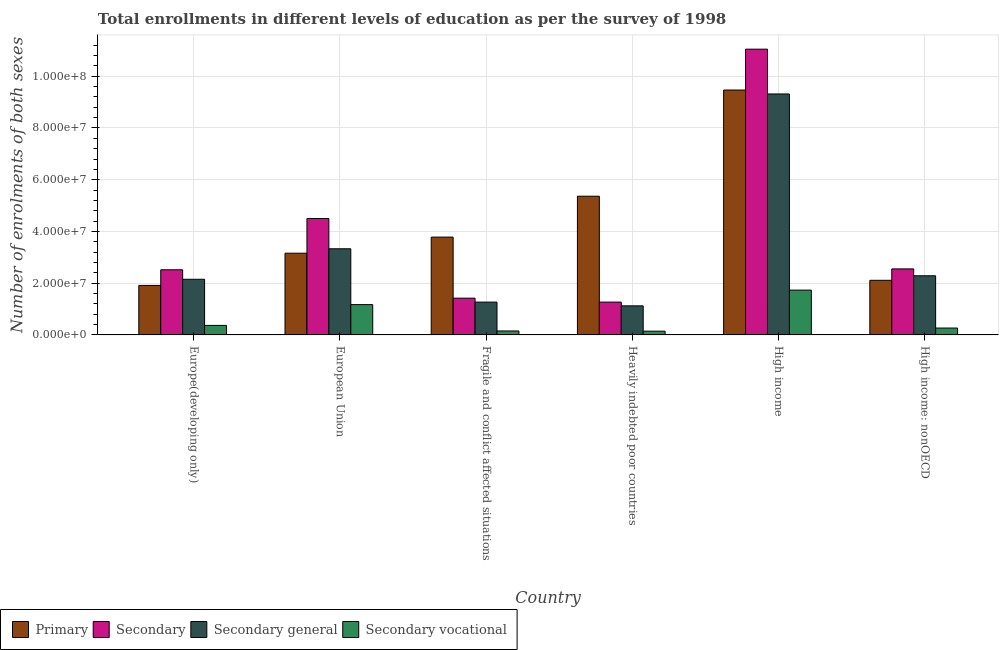How many different coloured bars are there?
Offer a very short reply. 4. How many bars are there on the 5th tick from the right?
Your answer should be very brief. 4. What is the label of the 4th group of bars from the left?
Your answer should be compact. Heavily indebted poor countries. What is the number of enrolments in primary education in Heavily indebted poor countries?
Your answer should be compact. 5.36e+07. Across all countries, what is the maximum number of enrolments in secondary education?
Your answer should be compact. 1.10e+08. Across all countries, what is the minimum number of enrolments in secondary education?
Make the answer very short. 1.27e+07. In which country was the number of enrolments in secondary general education maximum?
Provide a succinct answer. High income. In which country was the number of enrolments in secondary education minimum?
Offer a terse response. Heavily indebted poor countries. What is the total number of enrolments in primary education in the graph?
Your answer should be compact. 2.58e+08. What is the difference between the number of enrolments in secondary education in Europe(developing only) and that in Heavily indebted poor countries?
Your answer should be very brief. 1.25e+07. What is the difference between the number of enrolments in primary education in High income and the number of enrolments in secondary education in Fragile and conflict affected situations?
Make the answer very short. 8.05e+07. What is the average number of enrolments in secondary vocational education per country?
Ensure brevity in your answer.  6.39e+06. What is the difference between the number of enrolments in secondary education and number of enrolments in secondary vocational education in Europe(developing only)?
Give a very brief answer. 2.15e+07. What is the ratio of the number of enrolments in secondary general education in European Union to that in Fragile and conflict affected situations?
Provide a succinct answer. 2.63. What is the difference between the highest and the second highest number of enrolments in secondary vocational education?
Give a very brief answer. 5.61e+06. What is the difference between the highest and the lowest number of enrolments in secondary general education?
Your answer should be compact. 8.19e+07. In how many countries, is the number of enrolments in secondary vocational education greater than the average number of enrolments in secondary vocational education taken over all countries?
Your response must be concise. 2. Is it the case that in every country, the sum of the number of enrolments in secondary vocational education and number of enrolments in secondary general education is greater than the sum of number of enrolments in primary education and number of enrolments in secondary education?
Your response must be concise. No. What does the 2nd bar from the left in European Union represents?
Offer a very short reply. Secondary. What does the 3rd bar from the right in Fragile and conflict affected situations represents?
Ensure brevity in your answer.  Secondary. How many bars are there?
Ensure brevity in your answer.  24. Are all the bars in the graph horizontal?
Your response must be concise. No. How many countries are there in the graph?
Offer a terse response. 6. What is the difference between two consecutive major ticks on the Y-axis?
Your answer should be compact. 2.00e+07. Are the values on the major ticks of Y-axis written in scientific E-notation?
Your answer should be compact. Yes. Where does the legend appear in the graph?
Your answer should be compact. Bottom left. How many legend labels are there?
Provide a short and direct response. 4. How are the legend labels stacked?
Offer a terse response. Horizontal. What is the title of the graph?
Offer a very short reply. Total enrollments in different levels of education as per the survey of 1998. Does "Natural Gas" appear as one of the legend labels in the graph?
Provide a short and direct response. No. What is the label or title of the Y-axis?
Give a very brief answer. Number of enrolments of both sexes. What is the Number of enrolments of both sexes of Primary in Europe(developing only)?
Make the answer very short. 1.91e+07. What is the Number of enrolments of both sexes in Secondary in Europe(developing only)?
Offer a very short reply. 2.52e+07. What is the Number of enrolments of both sexes of Secondary general in Europe(developing only)?
Offer a terse response. 2.15e+07. What is the Number of enrolments of both sexes in Secondary vocational in Europe(developing only)?
Your answer should be compact. 3.67e+06. What is the Number of enrolments of both sexes in Primary in European Union?
Ensure brevity in your answer.  3.16e+07. What is the Number of enrolments of both sexes of Secondary in European Union?
Give a very brief answer. 4.50e+07. What is the Number of enrolments of both sexes of Secondary general in European Union?
Your response must be concise. 3.33e+07. What is the Number of enrolments of both sexes of Secondary vocational in European Union?
Provide a short and direct response. 1.17e+07. What is the Number of enrolments of both sexes of Primary in Fragile and conflict affected situations?
Your answer should be compact. 3.78e+07. What is the Number of enrolments of both sexes of Secondary in Fragile and conflict affected situations?
Ensure brevity in your answer.  1.42e+07. What is the Number of enrolments of both sexes in Secondary general in Fragile and conflict affected situations?
Provide a short and direct response. 1.27e+07. What is the Number of enrolments of both sexes of Secondary vocational in Fragile and conflict affected situations?
Offer a very short reply. 1.53e+06. What is the Number of enrolments of both sexes of Primary in Heavily indebted poor countries?
Your answer should be compact. 5.36e+07. What is the Number of enrolments of both sexes of Secondary in Heavily indebted poor countries?
Give a very brief answer. 1.27e+07. What is the Number of enrolments of both sexes in Secondary general in Heavily indebted poor countries?
Your answer should be very brief. 1.12e+07. What is the Number of enrolments of both sexes of Secondary vocational in Heavily indebted poor countries?
Your response must be concise. 1.45e+06. What is the Number of enrolments of both sexes of Primary in High income?
Provide a succinct answer. 9.47e+07. What is the Number of enrolments of both sexes of Secondary in High income?
Keep it short and to the point. 1.10e+08. What is the Number of enrolments of both sexes of Secondary general in High income?
Provide a short and direct response. 9.31e+07. What is the Number of enrolments of both sexes in Secondary vocational in High income?
Your answer should be compact. 1.73e+07. What is the Number of enrolments of both sexes in Primary in High income: nonOECD?
Your response must be concise. 2.11e+07. What is the Number of enrolments of both sexes in Secondary in High income: nonOECD?
Offer a very short reply. 2.55e+07. What is the Number of enrolments of both sexes of Secondary general in High income: nonOECD?
Your answer should be very brief. 2.29e+07. What is the Number of enrolments of both sexes in Secondary vocational in High income: nonOECD?
Offer a very short reply. 2.66e+06. Across all countries, what is the maximum Number of enrolments of both sexes in Primary?
Keep it short and to the point. 9.47e+07. Across all countries, what is the maximum Number of enrolments of both sexes of Secondary?
Provide a short and direct response. 1.10e+08. Across all countries, what is the maximum Number of enrolments of both sexes of Secondary general?
Make the answer very short. 9.31e+07. Across all countries, what is the maximum Number of enrolments of both sexes of Secondary vocational?
Ensure brevity in your answer.  1.73e+07. Across all countries, what is the minimum Number of enrolments of both sexes of Primary?
Your answer should be compact. 1.91e+07. Across all countries, what is the minimum Number of enrolments of both sexes in Secondary?
Your answer should be compact. 1.27e+07. Across all countries, what is the minimum Number of enrolments of both sexes of Secondary general?
Give a very brief answer. 1.12e+07. Across all countries, what is the minimum Number of enrolments of both sexes of Secondary vocational?
Provide a short and direct response. 1.45e+06. What is the total Number of enrolments of both sexes of Primary in the graph?
Your answer should be compact. 2.58e+08. What is the total Number of enrolments of both sexes of Secondary in the graph?
Give a very brief answer. 2.33e+08. What is the total Number of enrolments of both sexes in Secondary general in the graph?
Make the answer very short. 1.95e+08. What is the total Number of enrolments of both sexes of Secondary vocational in the graph?
Provide a succinct answer. 3.83e+07. What is the difference between the Number of enrolments of both sexes in Primary in Europe(developing only) and that in European Union?
Give a very brief answer. -1.25e+07. What is the difference between the Number of enrolments of both sexes of Secondary in Europe(developing only) and that in European Union?
Your answer should be very brief. -1.98e+07. What is the difference between the Number of enrolments of both sexes of Secondary general in Europe(developing only) and that in European Union?
Offer a very short reply. -1.18e+07. What is the difference between the Number of enrolments of both sexes in Secondary vocational in Europe(developing only) and that in European Union?
Give a very brief answer. -8.04e+06. What is the difference between the Number of enrolments of both sexes of Primary in Europe(developing only) and that in Fragile and conflict affected situations?
Offer a terse response. -1.87e+07. What is the difference between the Number of enrolments of both sexes in Secondary in Europe(developing only) and that in Fragile and conflict affected situations?
Give a very brief answer. 1.10e+07. What is the difference between the Number of enrolments of both sexes of Secondary general in Europe(developing only) and that in Fragile and conflict affected situations?
Make the answer very short. 8.83e+06. What is the difference between the Number of enrolments of both sexes in Secondary vocational in Europe(developing only) and that in Fragile and conflict affected situations?
Offer a terse response. 2.14e+06. What is the difference between the Number of enrolments of both sexes in Primary in Europe(developing only) and that in Heavily indebted poor countries?
Give a very brief answer. -3.45e+07. What is the difference between the Number of enrolments of both sexes in Secondary in Europe(developing only) and that in Heavily indebted poor countries?
Offer a terse response. 1.25e+07. What is the difference between the Number of enrolments of both sexes in Secondary general in Europe(developing only) and that in Heavily indebted poor countries?
Keep it short and to the point. 1.03e+07. What is the difference between the Number of enrolments of both sexes in Secondary vocational in Europe(developing only) and that in Heavily indebted poor countries?
Give a very brief answer. 2.22e+06. What is the difference between the Number of enrolments of both sexes in Primary in Europe(developing only) and that in High income?
Offer a very short reply. -7.55e+07. What is the difference between the Number of enrolments of both sexes of Secondary in Europe(developing only) and that in High income?
Make the answer very short. -8.53e+07. What is the difference between the Number of enrolments of both sexes of Secondary general in Europe(developing only) and that in High income?
Your response must be concise. -7.16e+07. What is the difference between the Number of enrolments of both sexes in Secondary vocational in Europe(developing only) and that in High income?
Give a very brief answer. -1.36e+07. What is the difference between the Number of enrolments of both sexes in Primary in Europe(developing only) and that in High income: nonOECD?
Provide a succinct answer. -1.98e+06. What is the difference between the Number of enrolments of both sexes of Secondary in Europe(developing only) and that in High income: nonOECD?
Your answer should be compact. -3.42e+05. What is the difference between the Number of enrolments of both sexes in Secondary general in Europe(developing only) and that in High income: nonOECD?
Your answer should be compact. -1.35e+06. What is the difference between the Number of enrolments of both sexes of Secondary vocational in Europe(developing only) and that in High income: nonOECD?
Your answer should be compact. 1.01e+06. What is the difference between the Number of enrolments of both sexes of Primary in European Union and that in Fragile and conflict affected situations?
Your answer should be compact. -6.23e+06. What is the difference between the Number of enrolments of both sexes of Secondary in European Union and that in Fragile and conflict affected situations?
Offer a terse response. 3.08e+07. What is the difference between the Number of enrolments of both sexes in Secondary general in European Union and that in Fragile and conflict affected situations?
Ensure brevity in your answer.  2.06e+07. What is the difference between the Number of enrolments of both sexes in Secondary vocational in European Union and that in Fragile and conflict affected situations?
Your answer should be very brief. 1.02e+07. What is the difference between the Number of enrolments of both sexes in Primary in European Union and that in Heavily indebted poor countries?
Make the answer very short. -2.20e+07. What is the difference between the Number of enrolments of both sexes in Secondary in European Union and that in Heavily indebted poor countries?
Offer a terse response. 3.23e+07. What is the difference between the Number of enrolments of both sexes in Secondary general in European Union and that in Heavily indebted poor countries?
Ensure brevity in your answer.  2.21e+07. What is the difference between the Number of enrolments of both sexes in Secondary vocational in European Union and that in Heavily indebted poor countries?
Offer a terse response. 1.03e+07. What is the difference between the Number of enrolments of both sexes in Primary in European Union and that in High income?
Provide a short and direct response. -6.31e+07. What is the difference between the Number of enrolments of both sexes in Secondary in European Union and that in High income?
Give a very brief answer. -6.55e+07. What is the difference between the Number of enrolments of both sexes of Secondary general in European Union and that in High income?
Ensure brevity in your answer.  -5.99e+07. What is the difference between the Number of enrolments of both sexes in Secondary vocational in European Union and that in High income?
Keep it short and to the point. -5.61e+06. What is the difference between the Number of enrolments of both sexes of Primary in European Union and that in High income: nonOECD?
Make the answer very short. 1.05e+07. What is the difference between the Number of enrolments of both sexes of Secondary in European Union and that in High income: nonOECD?
Provide a short and direct response. 1.95e+07. What is the difference between the Number of enrolments of both sexes of Secondary general in European Union and that in High income: nonOECD?
Offer a very short reply. 1.04e+07. What is the difference between the Number of enrolments of both sexes in Secondary vocational in European Union and that in High income: nonOECD?
Provide a short and direct response. 9.05e+06. What is the difference between the Number of enrolments of both sexes in Primary in Fragile and conflict affected situations and that in Heavily indebted poor countries?
Provide a short and direct response. -1.58e+07. What is the difference between the Number of enrolments of both sexes of Secondary in Fragile and conflict affected situations and that in Heavily indebted poor countries?
Your answer should be compact. 1.52e+06. What is the difference between the Number of enrolments of both sexes of Secondary general in Fragile and conflict affected situations and that in Heavily indebted poor countries?
Your answer should be very brief. 1.45e+06. What is the difference between the Number of enrolments of both sexes in Secondary vocational in Fragile and conflict affected situations and that in Heavily indebted poor countries?
Your response must be concise. 7.78e+04. What is the difference between the Number of enrolments of both sexes of Primary in Fragile and conflict affected situations and that in High income?
Your answer should be very brief. -5.69e+07. What is the difference between the Number of enrolments of both sexes in Secondary in Fragile and conflict affected situations and that in High income?
Offer a very short reply. -9.63e+07. What is the difference between the Number of enrolments of both sexes in Secondary general in Fragile and conflict affected situations and that in High income?
Provide a succinct answer. -8.05e+07. What is the difference between the Number of enrolments of both sexes of Secondary vocational in Fragile and conflict affected situations and that in High income?
Offer a terse response. -1.58e+07. What is the difference between the Number of enrolments of both sexes in Primary in Fragile and conflict affected situations and that in High income: nonOECD?
Provide a short and direct response. 1.67e+07. What is the difference between the Number of enrolments of both sexes in Secondary in Fragile and conflict affected situations and that in High income: nonOECD?
Your answer should be compact. -1.13e+07. What is the difference between the Number of enrolments of both sexes of Secondary general in Fragile and conflict affected situations and that in High income: nonOECD?
Ensure brevity in your answer.  -1.02e+07. What is the difference between the Number of enrolments of both sexes in Secondary vocational in Fragile and conflict affected situations and that in High income: nonOECD?
Your response must be concise. -1.13e+06. What is the difference between the Number of enrolments of both sexes of Primary in Heavily indebted poor countries and that in High income?
Offer a very short reply. -4.10e+07. What is the difference between the Number of enrolments of both sexes of Secondary in Heavily indebted poor countries and that in High income?
Provide a succinct answer. -9.78e+07. What is the difference between the Number of enrolments of both sexes in Secondary general in Heavily indebted poor countries and that in High income?
Offer a terse response. -8.19e+07. What is the difference between the Number of enrolments of both sexes in Secondary vocational in Heavily indebted poor countries and that in High income?
Give a very brief answer. -1.59e+07. What is the difference between the Number of enrolments of both sexes of Primary in Heavily indebted poor countries and that in High income: nonOECD?
Your answer should be very brief. 3.25e+07. What is the difference between the Number of enrolments of both sexes in Secondary in Heavily indebted poor countries and that in High income: nonOECD?
Your response must be concise. -1.28e+07. What is the difference between the Number of enrolments of both sexes in Secondary general in Heavily indebted poor countries and that in High income: nonOECD?
Your answer should be compact. -1.16e+07. What is the difference between the Number of enrolments of both sexes in Secondary vocational in Heavily indebted poor countries and that in High income: nonOECD?
Ensure brevity in your answer.  -1.21e+06. What is the difference between the Number of enrolments of both sexes of Primary in High income and that in High income: nonOECD?
Provide a short and direct response. 7.36e+07. What is the difference between the Number of enrolments of both sexes of Secondary in High income and that in High income: nonOECD?
Offer a terse response. 8.49e+07. What is the difference between the Number of enrolments of both sexes of Secondary general in High income and that in High income: nonOECD?
Give a very brief answer. 7.03e+07. What is the difference between the Number of enrolments of both sexes of Secondary vocational in High income and that in High income: nonOECD?
Make the answer very short. 1.47e+07. What is the difference between the Number of enrolments of both sexes in Primary in Europe(developing only) and the Number of enrolments of both sexes in Secondary in European Union?
Give a very brief answer. -2.59e+07. What is the difference between the Number of enrolments of both sexes in Primary in Europe(developing only) and the Number of enrolments of both sexes in Secondary general in European Union?
Provide a short and direct response. -1.42e+07. What is the difference between the Number of enrolments of both sexes in Primary in Europe(developing only) and the Number of enrolments of both sexes in Secondary vocational in European Union?
Give a very brief answer. 7.42e+06. What is the difference between the Number of enrolments of both sexes in Secondary in Europe(developing only) and the Number of enrolments of both sexes in Secondary general in European Union?
Ensure brevity in your answer.  -8.12e+06. What is the difference between the Number of enrolments of both sexes of Secondary in Europe(developing only) and the Number of enrolments of both sexes of Secondary vocational in European Union?
Provide a succinct answer. 1.35e+07. What is the difference between the Number of enrolments of both sexes of Secondary general in Europe(developing only) and the Number of enrolments of both sexes of Secondary vocational in European Union?
Offer a terse response. 9.80e+06. What is the difference between the Number of enrolments of both sexes of Primary in Europe(developing only) and the Number of enrolments of both sexes of Secondary in Fragile and conflict affected situations?
Provide a succinct answer. 4.92e+06. What is the difference between the Number of enrolments of both sexes in Primary in Europe(developing only) and the Number of enrolments of both sexes in Secondary general in Fragile and conflict affected situations?
Offer a very short reply. 6.45e+06. What is the difference between the Number of enrolments of both sexes of Primary in Europe(developing only) and the Number of enrolments of both sexes of Secondary vocational in Fragile and conflict affected situations?
Make the answer very short. 1.76e+07. What is the difference between the Number of enrolments of both sexes of Secondary in Europe(developing only) and the Number of enrolments of both sexes of Secondary general in Fragile and conflict affected situations?
Provide a short and direct response. 1.25e+07. What is the difference between the Number of enrolments of both sexes in Secondary in Europe(developing only) and the Number of enrolments of both sexes in Secondary vocational in Fragile and conflict affected situations?
Offer a very short reply. 2.37e+07. What is the difference between the Number of enrolments of both sexes in Secondary general in Europe(developing only) and the Number of enrolments of both sexes in Secondary vocational in Fragile and conflict affected situations?
Your answer should be compact. 2.00e+07. What is the difference between the Number of enrolments of both sexes in Primary in Europe(developing only) and the Number of enrolments of both sexes in Secondary in Heavily indebted poor countries?
Keep it short and to the point. 6.45e+06. What is the difference between the Number of enrolments of both sexes in Primary in Europe(developing only) and the Number of enrolments of both sexes in Secondary general in Heavily indebted poor countries?
Provide a short and direct response. 7.90e+06. What is the difference between the Number of enrolments of both sexes of Primary in Europe(developing only) and the Number of enrolments of both sexes of Secondary vocational in Heavily indebted poor countries?
Provide a short and direct response. 1.77e+07. What is the difference between the Number of enrolments of both sexes in Secondary in Europe(developing only) and the Number of enrolments of both sexes in Secondary general in Heavily indebted poor countries?
Make the answer very short. 1.39e+07. What is the difference between the Number of enrolments of both sexes in Secondary in Europe(developing only) and the Number of enrolments of both sexes in Secondary vocational in Heavily indebted poor countries?
Offer a very short reply. 2.37e+07. What is the difference between the Number of enrolments of both sexes of Secondary general in Europe(developing only) and the Number of enrolments of both sexes of Secondary vocational in Heavily indebted poor countries?
Give a very brief answer. 2.01e+07. What is the difference between the Number of enrolments of both sexes in Primary in Europe(developing only) and the Number of enrolments of both sexes in Secondary in High income?
Your answer should be compact. -9.13e+07. What is the difference between the Number of enrolments of both sexes of Primary in Europe(developing only) and the Number of enrolments of both sexes of Secondary general in High income?
Offer a very short reply. -7.40e+07. What is the difference between the Number of enrolments of both sexes in Primary in Europe(developing only) and the Number of enrolments of both sexes in Secondary vocational in High income?
Your answer should be compact. 1.81e+06. What is the difference between the Number of enrolments of both sexes in Secondary in Europe(developing only) and the Number of enrolments of both sexes in Secondary general in High income?
Provide a short and direct response. -6.80e+07. What is the difference between the Number of enrolments of both sexes in Secondary in Europe(developing only) and the Number of enrolments of both sexes in Secondary vocational in High income?
Your response must be concise. 7.86e+06. What is the difference between the Number of enrolments of both sexes of Secondary general in Europe(developing only) and the Number of enrolments of both sexes of Secondary vocational in High income?
Give a very brief answer. 4.19e+06. What is the difference between the Number of enrolments of both sexes of Primary in Europe(developing only) and the Number of enrolments of both sexes of Secondary in High income: nonOECD?
Provide a short and direct response. -6.39e+06. What is the difference between the Number of enrolments of both sexes of Primary in Europe(developing only) and the Number of enrolments of both sexes of Secondary general in High income: nonOECD?
Your response must be concise. -3.73e+06. What is the difference between the Number of enrolments of both sexes in Primary in Europe(developing only) and the Number of enrolments of both sexes in Secondary vocational in High income: nonOECD?
Your answer should be very brief. 1.65e+07. What is the difference between the Number of enrolments of both sexes of Secondary in Europe(developing only) and the Number of enrolments of both sexes of Secondary general in High income: nonOECD?
Give a very brief answer. 2.32e+06. What is the difference between the Number of enrolments of both sexes in Secondary in Europe(developing only) and the Number of enrolments of both sexes in Secondary vocational in High income: nonOECD?
Offer a very short reply. 2.25e+07. What is the difference between the Number of enrolments of both sexes of Secondary general in Europe(developing only) and the Number of enrolments of both sexes of Secondary vocational in High income: nonOECD?
Make the answer very short. 1.89e+07. What is the difference between the Number of enrolments of both sexes in Primary in European Union and the Number of enrolments of both sexes in Secondary in Fragile and conflict affected situations?
Ensure brevity in your answer.  1.74e+07. What is the difference between the Number of enrolments of both sexes in Primary in European Union and the Number of enrolments of both sexes in Secondary general in Fragile and conflict affected situations?
Give a very brief answer. 1.89e+07. What is the difference between the Number of enrolments of both sexes in Primary in European Union and the Number of enrolments of both sexes in Secondary vocational in Fragile and conflict affected situations?
Provide a succinct answer. 3.01e+07. What is the difference between the Number of enrolments of both sexes of Secondary in European Union and the Number of enrolments of both sexes of Secondary general in Fragile and conflict affected situations?
Provide a succinct answer. 3.23e+07. What is the difference between the Number of enrolments of both sexes in Secondary in European Union and the Number of enrolments of both sexes in Secondary vocational in Fragile and conflict affected situations?
Offer a very short reply. 4.35e+07. What is the difference between the Number of enrolments of both sexes in Secondary general in European Union and the Number of enrolments of both sexes in Secondary vocational in Fragile and conflict affected situations?
Your answer should be compact. 3.18e+07. What is the difference between the Number of enrolments of both sexes in Primary in European Union and the Number of enrolments of both sexes in Secondary in Heavily indebted poor countries?
Your answer should be compact. 1.89e+07. What is the difference between the Number of enrolments of both sexes in Primary in European Union and the Number of enrolments of both sexes in Secondary general in Heavily indebted poor countries?
Provide a short and direct response. 2.04e+07. What is the difference between the Number of enrolments of both sexes in Primary in European Union and the Number of enrolments of both sexes in Secondary vocational in Heavily indebted poor countries?
Offer a very short reply. 3.01e+07. What is the difference between the Number of enrolments of both sexes in Secondary in European Union and the Number of enrolments of both sexes in Secondary general in Heavily indebted poor countries?
Provide a short and direct response. 3.38e+07. What is the difference between the Number of enrolments of both sexes in Secondary in European Union and the Number of enrolments of both sexes in Secondary vocational in Heavily indebted poor countries?
Your answer should be compact. 4.36e+07. What is the difference between the Number of enrolments of both sexes of Secondary general in European Union and the Number of enrolments of both sexes of Secondary vocational in Heavily indebted poor countries?
Your answer should be compact. 3.18e+07. What is the difference between the Number of enrolments of both sexes of Primary in European Union and the Number of enrolments of both sexes of Secondary in High income?
Keep it short and to the point. -7.89e+07. What is the difference between the Number of enrolments of both sexes in Primary in European Union and the Number of enrolments of both sexes in Secondary general in High income?
Offer a terse response. -6.16e+07. What is the difference between the Number of enrolments of both sexes of Primary in European Union and the Number of enrolments of both sexes of Secondary vocational in High income?
Your response must be concise. 1.43e+07. What is the difference between the Number of enrolments of both sexes of Secondary in European Union and the Number of enrolments of both sexes of Secondary general in High income?
Provide a succinct answer. -4.81e+07. What is the difference between the Number of enrolments of both sexes of Secondary in European Union and the Number of enrolments of both sexes of Secondary vocational in High income?
Your answer should be compact. 2.77e+07. What is the difference between the Number of enrolments of both sexes of Secondary general in European Union and the Number of enrolments of both sexes of Secondary vocational in High income?
Provide a short and direct response. 1.60e+07. What is the difference between the Number of enrolments of both sexes in Primary in European Union and the Number of enrolments of both sexes in Secondary in High income: nonOECD?
Your response must be concise. 6.07e+06. What is the difference between the Number of enrolments of both sexes in Primary in European Union and the Number of enrolments of both sexes in Secondary general in High income: nonOECD?
Provide a succinct answer. 8.72e+06. What is the difference between the Number of enrolments of both sexes in Primary in European Union and the Number of enrolments of both sexes in Secondary vocational in High income: nonOECD?
Provide a succinct answer. 2.89e+07. What is the difference between the Number of enrolments of both sexes in Secondary in European Union and the Number of enrolments of both sexes in Secondary general in High income: nonOECD?
Make the answer very short. 2.21e+07. What is the difference between the Number of enrolments of both sexes of Secondary in European Union and the Number of enrolments of both sexes of Secondary vocational in High income: nonOECD?
Your answer should be compact. 4.23e+07. What is the difference between the Number of enrolments of both sexes of Secondary general in European Union and the Number of enrolments of both sexes of Secondary vocational in High income: nonOECD?
Ensure brevity in your answer.  3.06e+07. What is the difference between the Number of enrolments of both sexes in Primary in Fragile and conflict affected situations and the Number of enrolments of both sexes in Secondary in Heavily indebted poor countries?
Offer a terse response. 2.51e+07. What is the difference between the Number of enrolments of both sexes in Primary in Fragile and conflict affected situations and the Number of enrolments of both sexes in Secondary general in Heavily indebted poor countries?
Your response must be concise. 2.66e+07. What is the difference between the Number of enrolments of both sexes in Primary in Fragile and conflict affected situations and the Number of enrolments of both sexes in Secondary vocational in Heavily indebted poor countries?
Your response must be concise. 3.64e+07. What is the difference between the Number of enrolments of both sexes of Secondary in Fragile and conflict affected situations and the Number of enrolments of both sexes of Secondary general in Heavily indebted poor countries?
Make the answer very short. 2.97e+06. What is the difference between the Number of enrolments of both sexes in Secondary in Fragile and conflict affected situations and the Number of enrolments of both sexes in Secondary vocational in Heavily indebted poor countries?
Keep it short and to the point. 1.28e+07. What is the difference between the Number of enrolments of both sexes in Secondary general in Fragile and conflict affected situations and the Number of enrolments of both sexes in Secondary vocational in Heavily indebted poor countries?
Provide a succinct answer. 1.12e+07. What is the difference between the Number of enrolments of both sexes of Primary in Fragile and conflict affected situations and the Number of enrolments of both sexes of Secondary in High income?
Your answer should be very brief. -7.27e+07. What is the difference between the Number of enrolments of both sexes in Primary in Fragile and conflict affected situations and the Number of enrolments of both sexes in Secondary general in High income?
Offer a terse response. -5.53e+07. What is the difference between the Number of enrolments of both sexes in Primary in Fragile and conflict affected situations and the Number of enrolments of both sexes in Secondary vocational in High income?
Provide a succinct answer. 2.05e+07. What is the difference between the Number of enrolments of both sexes of Secondary in Fragile and conflict affected situations and the Number of enrolments of both sexes of Secondary general in High income?
Make the answer very short. -7.89e+07. What is the difference between the Number of enrolments of both sexes in Secondary in Fragile and conflict affected situations and the Number of enrolments of both sexes in Secondary vocational in High income?
Provide a succinct answer. -3.11e+06. What is the difference between the Number of enrolments of both sexes of Secondary general in Fragile and conflict affected situations and the Number of enrolments of both sexes of Secondary vocational in High income?
Provide a short and direct response. -4.64e+06. What is the difference between the Number of enrolments of both sexes in Primary in Fragile and conflict affected situations and the Number of enrolments of both sexes in Secondary in High income: nonOECD?
Provide a succinct answer. 1.23e+07. What is the difference between the Number of enrolments of both sexes in Primary in Fragile and conflict affected situations and the Number of enrolments of both sexes in Secondary general in High income: nonOECD?
Your response must be concise. 1.50e+07. What is the difference between the Number of enrolments of both sexes in Primary in Fragile and conflict affected situations and the Number of enrolments of both sexes in Secondary vocational in High income: nonOECD?
Keep it short and to the point. 3.52e+07. What is the difference between the Number of enrolments of both sexes in Secondary in Fragile and conflict affected situations and the Number of enrolments of both sexes in Secondary general in High income: nonOECD?
Ensure brevity in your answer.  -8.65e+06. What is the difference between the Number of enrolments of both sexes in Secondary in Fragile and conflict affected situations and the Number of enrolments of both sexes in Secondary vocational in High income: nonOECD?
Give a very brief answer. 1.16e+07. What is the difference between the Number of enrolments of both sexes of Secondary general in Fragile and conflict affected situations and the Number of enrolments of both sexes of Secondary vocational in High income: nonOECD?
Ensure brevity in your answer.  1.00e+07. What is the difference between the Number of enrolments of both sexes of Primary in Heavily indebted poor countries and the Number of enrolments of both sexes of Secondary in High income?
Provide a succinct answer. -5.68e+07. What is the difference between the Number of enrolments of both sexes of Primary in Heavily indebted poor countries and the Number of enrolments of both sexes of Secondary general in High income?
Offer a terse response. -3.95e+07. What is the difference between the Number of enrolments of both sexes in Primary in Heavily indebted poor countries and the Number of enrolments of both sexes in Secondary vocational in High income?
Offer a very short reply. 3.63e+07. What is the difference between the Number of enrolments of both sexes in Secondary in Heavily indebted poor countries and the Number of enrolments of both sexes in Secondary general in High income?
Ensure brevity in your answer.  -8.05e+07. What is the difference between the Number of enrolments of both sexes of Secondary in Heavily indebted poor countries and the Number of enrolments of both sexes of Secondary vocational in High income?
Provide a succinct answer. -4.63e+06. What is the difference between the Number of enrolments of both sexes of Secondary general in Heavily indebted poor countries and the Number of enrolments of both sexes of Secondary vocational in High income?
Your answer should be compact. -6.08e+06. What is the difference between the Number of enrolments of both sexes of Primary in Heavily indebted poor countries and the Number of enrolments of both sexes of Secondary in High income: nonOECD?
Ensure brevity in your answer.  2.81e+07. What is the difference between the Number of enrolments of both sexes of Primary in Heavily indebted poor countries and the Number of enrolments of both sexes of Secondary general in High income: nonOECD?
Provide a succinct answer. 3.08e+07. What is the difference between the Number of enrolments of both sexes of Primary in Heavily indebted poor countries and the Number of enrolments of both sexes of Secondary vocational in High income: nonOECD?
Make the answer very short. 5.10e+07. What is the difference between the Number of enrolments of both sexes of Secondary in Heavily indebted poor countries and the Number of enrolments of both sexes of Secondary general in High income: nonOECD?
Provide a short and direct response. -1.02e+07. What is the difference between the Number of enrolments of both sexes of Secondary in Heavily indebted poor countries and the Number of enrolments of both sexes of Secondary vocational in High income: nonOECD?
Offer a terse response. 1.00e+07. What is the difference between the Number of enrolments of both sexes of Secondary general in Heavily indebted poor countries and the Number of enrolments of both sexes of Secondary vocational in High income: nonOECD?
Provide a succinct answer. 8.58e+06. What is the difference between the Number of enrolments of both sexes in Primary in High income and the Number of enrolments of both sexes in Secondary in High income: nonOECD?
Keep it short and to the point. 6.91e+07. What is the difference between the Number of enrolments of both sexes of Primary in High income and the Number of enrolments of both sexes of Secondary general in High income: nonOECD?
Your answer should be compact. 7.18e+07. What is the difference between the Number of enrolments of both sexes of Primary in High income and the Number of enrolments of both sexes of Secondary vocational in High income: nonOECD?
Ensure brevity in your answer.  9.20e+07. What is the difference between the Number of enrolments of both sexes in Secondary in High income and the Number of enrolments of both sexes in Secondary general in High income: nonOECD?
Your response must be concise. 8.76e+07. What is the difference between the Number of enrolments of both sexes in Secondary in High income and the Number of enrolments of both sexes in Secondary vocational in High income: nonOECD?
Your answer should be compact. 1.08e+08. What is the difference between the Number of enrolments of both sexes in Secondary general in High income and the Number of enrolments of both sexes in Secondary vocational in High income: nonOECD?
Keep it short and to the point. 9.05e+07. What is the average Number of enrolments of both sexes in Primary per country?
Make the answer very short. 4.30e+07. What is the average Number of enrolments of both sexes of Secondary per country?
Your answer should be compact. 3.88e+07. What is the average Number of enrolments of both sexes in Secondary general per country?
Keep it short and to the point. 3.25e+07. What is the average Number of enrolments of both sexes in Secondary vocational per country?
Keep it short and to the point. 6.39e+06. What is the difference between the Number of enrolments of both sexes of Primary and Number of enrolments of both sexes of Secondary in Europe(developing only)?
Provide a short and direct response. -6.05e+06. What is the difference between the Number of enrolments of both sexes of Primary and Number of enrolments of both sexes of Secondary general in Europe(developing only)?
Your answer should be very brief. -2.38e+06. What is the difference between the Number of enrolments of both sexes of Primary and Number of enrolments of both sexes of Secondary vocational in Europe(developing only)?
Ensure brevity in your answer.  1.55e+07. What is the difference between the Number of enrolments of both sexes of Secondary and Number of enrolments of both sexes of Secondary general in Europe(developing only)?
Offer a very short reply. 3.67e+06. What is the difference between the Number of enrolments of both sexes of Secondary and Number of enrolments of both sexes of Secondary vocational in Europe(developing only)?
Make the answer very short. 2.15e+07. What is the difference between the Number of enrolments of both sexes of Secondary general and Number of enrolments of both sexes of Secondary vocational in Europe(developing only)?
Offer a terse response. 1.78e+07. What is the difference between the Number of enrolments of both sexes in Primary and Number of enrolments of both sexes in Secondary in European Union?
Provide a succinct answer. -1.34e+07. What is the difference between the Number of enrolments of both sexes of Primary and Number of enrolments of both sexes of Secondary general in European Union?
Make the answer very short. -1.71e+06. What is the difference between the Number of enrolments of both sexes in Primary and Number of enrolments of both sexes in Secondary vocational in European Union?
Provide a succinct answer. 1.99e+07. What is the difference between the Number of enrolments of both sexes of Secondary and Number of enrolments of both sexes of Secondary general in European Union?
Offer a very short reply. 1.17e+07. What is the difference between the Number of enrolments of both sexes of Secondary and Number of enrolments of both sexes of Secondary vocational in European Union?
Your response must be concise. 3.33e+07. What is the difference between the Number of enrolments of both sexes in Secondary general and Number of enrolments of both sexes in Secondary vocational in European Union?
Provide a short and direct response. 2.16e+07. What is the difference between the Number of enrolments of both sexes in Primary and Number of enrolments of both sexes in Secondary in Fragile and conflict affected situations?
Your answer should be compact. 2.36e+07. What is the difference between the Number of enrolments of both sexes of Primary and Number of enrolments of both sexes of Secondary general in Fragile and conflict affected situations?
Your answer should be very brief. 2.51e+07. What is the difference between the Number of enrolments of both sexes in Primary and Number of enrolments of both sexes in Secondary vocational in Fragile and conflict affected situations?
Give a very brief answer. 3.63e+07. What is the difference between the Number of enrolments of both sexes of Secondary and Number of enrolments of both sexes of Secondary general in Fragile and conflict affected situations?
Ensure brevity in your answer.  1.53e+06. What is the difference between the Number of enrolments of both sexes of Secondary and Number of enrolments of both sexes of Secondary vocational in Fragile and conflict affected situations?
Your answer should be very brief. 1.27e+07. What is the difference between the Number of enrolments of both sexes in Secondary general and Number of enrolments of both sexes in Secondary vocational in Fragile and conflict affected situations?
Offer a very short reply. 1.12e+07. What is the difference between the Number of enrolments of both sexes of Primary and Number of enrolments of both sexes of Secondary in Heavily indebted poor countries?
Your answer should be very brief. 4.09e+07. What is the difference between the Number of enrolments of both sexes in Primary and Number of enrolments of both sexes in Secondary general in Heavily indebted poor countries?
Provide a succinct answer. 4.24e+07. What is the difference between the Number of enrolments of both sexes of Primary and Number of enrolments of both sexes of Secondary vocational in Heavily indebted poor countries?
Your answer should be compact. 5.22e+07. What is the difference between the Number of enrolments of both sexes of Secondary and Number of enrolments of both sexes of Secondary general in Heavily indebted poor countries?
Your answer should be very brief. 1.45e+06. What is the difference between the Number of enrolments of both sexes in Secondary and Number of enrolments of both sexes in Secondary vocational in Heavily indebted poor countries?
Your response must be concise. 1.12e+07. What is the difference between the Number of enrolments of both sexes in Secondary general and Number of enrolments of both sexes in Secondary vocational in Heavily indebted poor countries?
Give a very brief answer. 9.78e+06. What is the difference between the Number of enrolments of both sexes of Primary and Number of enrolments of both sexes of Secondary in High income?
Offer a terse response. -1.58e+07. What is the difference between the Number of enrolments of both sexes of Primary and Number of enrolments of both sexes of Secondary general in High income?
Your answer should be compact. 1.52e+06. What is the difference between the Number of enrolments of both sexes in Primary and Number of enrolments of both sexes in Secondary vocational in High income?
Keep it short and to the point. 7.73e+07. What is the difference between the Number of enrolments of both sexes in Secondary and Number of enrolments of both sexes in Secondary general in High income?
Offer a very short reply. 1.73e+07. What is the difference between the Number of enrolments of both sexes in Secondary and Number of enrolments of both sexes in Secondary vocational in High income?
Give a very brief answer. 9.31e+07. What is the difference between the Number of enrolments of both sexes of Secondary general and Number of enrolments of both sexes of Secondary vocational in High income?
Give a very brief answer. 7.58e+07. What is the difference between the Number of enrolments of both sexes in Primary and Number of enrolments of both sexes in Secondary in High income: nonOECD?
Ensure brevity in your answer.  -4.41e+06. What is the difference between the Number of enrolments of both sexes in Primary and Number of enrolments of both sexes in Secondary general in High income: nonOECD?
Keep it short and to the point. -1.75e+06. What is the difference between the Number of enrolments of both sexes of Primary and Number of enrolments of both sexes of Secondary vocational in High income: nonOECD?
Provide a succinct answer. 1.85e+07. What is the difference between the Number of enrolments of both sexes of Secondary and Number of enrolments of both sexes of Secondary general in High income: nonOECD?
Your answer should be compact. 2.66e+06. What is the difference between the Number of enrolments of both sexes of Secondary and Number of enrolments of both sexes of Secondary vocational in High income: nonOECD?
Your answer should be very brief. 2.29e+07. What is the difference between the Number of enrolments of both sexes of Secondary general and Number of enrolments of both sexes of Secondary vocational in High income: nonOECD?
Offer a very short reply. 2.02e+07. What is the ratio of the Number of enrolments of both sexes in Primary in Europe(developing only) to that in European Union?
Offer a very short reply. 0.61. What is the ratio of the Number of enrolments of both sexes of Secondary in Europe(developing only) to that in European Union?
Offer a very short reply. 0.56. What is the ratio of the Number of enrolments of both sexes in Secondary general in Europe(developing only) to that in European Union?
Provide a short and direct response. 0.65. What is the ratio of the Number of enrolments of both sexes of Secondary vocational in Europe(developing only) to that in European Union?
Provide a short and direct response. 0.31. What is the ratio of the Number of enrolments of both sexes of Primary in Europe(developing only) to that in Fragile and conflict affected situations?
Your answer should be compact. 0.51. What is the ratio of the Number of enrolments of both sexes of Secondary in Europe(developing only) to that in Fragile and conflict affected situations?
Your answer should be very brief. 1.77. What is the ratio of the Number of enrolments of both sexes in Secondary general in Europe(developing only) to that in Fragile and conflict affected situations?
Your response must be concise. 1.7. What is the ratio of the Number of enrolments of both sexes in Secondary vocational in Europe(developing only) to that in Fragile and conflict affected situations?
Keep it short and to the point. 2.4. What is the ratio of the Number of enrolments of both sexes in Primary in Europe(developing only) to that in Heavily indebted poor countries?
Keep it short and to the point. 0.36. What is the ratio of the Number of enrolments of both sexes in Secondary in Europe(developing only) to that in Heavily indebted poor countries?
Offer a terse response. 1.99. What is the ratio of the Number of enrolments of both sexes of Secondary general in Europe(developing only) to that in Heavily indebted poor countries?
Your answer should be compact. 1.91. What is the ratio of the Number of enrolments of both sexes in Secondary vocational in Europe(developing only) to that in Heavily indebted poor countries?
Keep it short and to the point. 2.53. What is the ratio of the Number of enrolments of both sexes in Primary in Europe(developing only) to that in High income?
Keep it short and to the point. 0.2. What is the ratio of the Number of enrolments of both sexes of Secondary in Europe(developing only) to that in High income?
Offer a terse response. 0.23. What is the ratio of the Number of enrolments of both sexes in Secondary general in Europe(developing only) to that in High income?
Offer a terse response. 0.23. What is the ratio of the Number of enrolments of both sexes in Secondary vocational in Europe(developing only) to that in High income?
Provide a short and direct response. 0.21. What is the ratio of the Number of enrolments of both sexes of Primary in Europe(developing only) to that in High income: nonOECD?
Your response must be concise. 0.91. What is the ratio of the Number of enrolments of both sexes of Secondary in Europe(developing only) to that in High income: nonOECD?
Keep it short and to the point. 0.99. What is the ratio of the Number of enrolments of both sexes of Secondary general in Europe(developing only) to that in High income: nonOECD?
Ensure brevity in your answer.  0.94. What is the ratio of the Number of enrolments of both sexes in Secondary vocational in Europe(developing only) to that in High income: nonOECD?
Make the answer very short. 1.38. What is the ratio of the Number of enrolments of both sexes of Primary in European Union to that in Fragile and conflict affected situations?
Provide a succinct answer. 0.84. What is the ratio of the Number of enrolments of both sexes of Secondary in European Union to that in Fragile and conflict affected situations?
Offer a very short reply. 3.17. What is the ratio of the Number of enrolments of both sexes of Secondary general in European Union to that in Fragile and conflict affected situations?
Your answer should be very brief. 2.63. What is the ratio of the Number of enrolments of both sexes of Secondary vocational in European Union to that in Fragile and conflict affected situations?
Provide a short and direct response. 7.66. What is the ratio of the Number of enrolments of both sexes of Primary in European Union to that in Heavily indebted poor countries?
Ensure brevity in your answer.  0.59. What is the ratio of the Number of enrolments of both sexes of Secondary in European Union to that in Heavily indebted poor countries?
Your answer should be very brief. 3.55. What is the ratio of the Number of enrolments of both sexes in Secondary general in European Union to that in Heavily indebted poor countries?
Your answer should be very brief. 2.96. What is the ratio of the Number of enrolments of both sexes in Secondary vocational in European Union to that in Heavily indebted poor countries?
Your answer should be compact. 8.07. What is the ratio of the Number of enrolments of both sexes of Primary in European Union to that in High income?
Offer a terse response. 0.33. What is the ratio of the Number of enrolments of both sexes of Secondary in European Union to that in High income?
Your answer should be compact. 0.41. What is the ratio of the Number of enrolments of both sexes in Secondary general in European Union to that in High income?
Provide a short and direct response. 0.36. What is the ratio of the Number of enrolments of both sexes in Secondary vocational in European Union to that in High income?
Ensure brevity in your answer.  0.68. What is the ratio of the Number of enrolments of both sexes of Primary in European Union to that in High income: nonOECD?
Offer a very short reply. 1.5. What is the ratio of the Number of enrolments of both sexes in Secondary in European Union to that in High income: nonOECD?
Your answer should be compact. 1.76. What is the ratio of the Number of enrolments of both sexes of Secondary general in European Union to that in High income: nonOECD?
Keep it short and to the point. 1.46. What is the ratio of the Number of enrolments of both sexes of Secondary vocational in European Union to that in High income: nonOECD?
Offer a terse response. 4.4. What is the ratio of the Number of enrolments of both sexes of Primary in Fragile and conflict affected situations to that in Heavily indebted poor countries?
Offer a very short reply. 0.71. What is the ratio of the Number of enrolments of both sexes of Secondary in Fragile and conflict affected situations to that in Heavily indebted poor countries?
Provide a short and direct response. 1.12. What is the ratio of the Number of enrolments of both sexes of Secondary general in Fragile and conflict affected situations to that in Heavily indebted poor countries?
Provide a short and direct response. 1.13. What is the ratio of the Number of enrolments of both sexes in Secondary vocational in Fragile and conflict affected situations to that in Heavily indebted poor countries?
Your answer should be very brief. 1.05. What is the ratio of the Number of enrolments of both sexes of Primary in Fragile and conflict affected situations to that in High income?
Make the answer very short. 0.4. What is the ratio of the Number of enrolments of both sexes of Secondary in Fragile and conflict affected situations to that in High income?
Offer a terse response. 0.13. What is the ratio of the Number of enrolments of both sexes of Secondary general in Fragile and conflict affected situations to that in High income?
Give a very brief answer. 0.14. What is the ratio of the Number of enrolments of both sexes in Secondary vocational in Fragile and conflict affected situations to that in High income?
Provide a short and direct response. 0.09. What is the ratio of the Number of enrolments of both sexes of Primary in Fragile and conflict affected situations to that in High income: nonOECD?
Your answer should be very brief. 1.79. What is the ratio of the Number of enrolments of both sexes in Secondary in Fragile and conflict affected situations to that in High income: nonOECD?
Ensure brevity in your answer.  0.56. What is the ratio of the Number of enrolments of both sexes in Secondary general in Fragile and conflict affected situations to that in High income: nonOECD?
Your answer should be very brief. 0.55. What is the ratio of the Number of enrolments of both sexes of Secondary vocational in Fragile and conflict affected situations to that in High income: nonOECD?
Your answer should be very brief. 0.57. What is the ratio of the Number of enrolments of both sexes in Primary in Heavily indebted poor countries to that in High income?
Make the answer very short. 0.57. What is the ratio of the Number of enrolments of both sexes in Secondary in Heavily indebted poor countries to that in High income?
Offer a terse response. 0.11. What is the ratio of the Number of enrolments of both sexes in Secondary general in Heavily indebted poor countries to that in High income?
Give a very brief answer. 0.12. What is the ratio of the Number of enrolments of both sexes of Secondary vocational in Heavily indebted poor countries to that in High income?
Provide a short and direct response. 0.08. What is the ratio of the Number of enrolments of both sexes of Primary in Heavily indebted poor countries to that in High income: nonOECD?
Your response must be concise. 2.54. What is the ratio of the Number of enrolments of both sexes of Secondary in Heavily indebted poor countries to that in High income: nonOECD?
Offer a very short reply. 0.5. What is the ratio of the Number of enrolments of both sexes in Secondary general in Heavily indebted poor countries to that in High income: nonOECD?
Provide a short and direct response. 0.49. What is the ratio of the Number of enrolments of both sexes in Secondary vocational in Heavily indebted poor countries to that in High income: nonOECD?
Provide a short and direct response. 0.55. What is the ratio of the Number of enrolments of both sexes in Primary in High income to that in High income: nonOECD?
Your answer should be very brief. 4.48. What is the ratio of the Number of enrolments of both sexes of Secondary in High income to that in High income: nonOECD?
Give a very brief answer. 4.33. What is the ratio of the Number of enrolments of both sexes of Secondary general in High income to that in High income: nonOECD?
Offer a terse response. 4.07. What is the ratio of the Number of enrolments of both sexes in Secondary vocational in High income to that in High income: nonOECD?
Provide a succinct answer. 6.51. What is the difference between the highest and the second highest Number of enrolments of both sexes of Primary?
Provide a short and direct response. 4.10e+07. What is the difference between the highest and the second highest Number of enrolments of both sexes in Secondary?
Provide a short and direct response. 6.55e+07. What is the difference between the highest and the second highest Number of enrolments of both sexes in Secondary general?
Ensure brevity in your answer.  5.99e+07. What is the difference between the highest and the second highest Number of enrolments of both sexes of Secondary vocational?
Ensure brevity in your answer.  5.61e+06. What is the difference between the highest and the lowest Number of enrolments of both sexes in Primary?
Provide a short and direct response. 7.55e+07. What is the difference between the highest and the lowest Number of enrolments of both sexes in Secondary?
Keep it short and to the point. 9.78e+07. What is the difference between the highest and the lowest Number of enrolments of both sexes of Secondary general?
Give a very brief answer. 8.19e+07. What is the difference between the highest and the lowest Number of enrolments of both sexes in Secondary vocational?
Offer a very short reply. 1.59e+07. 